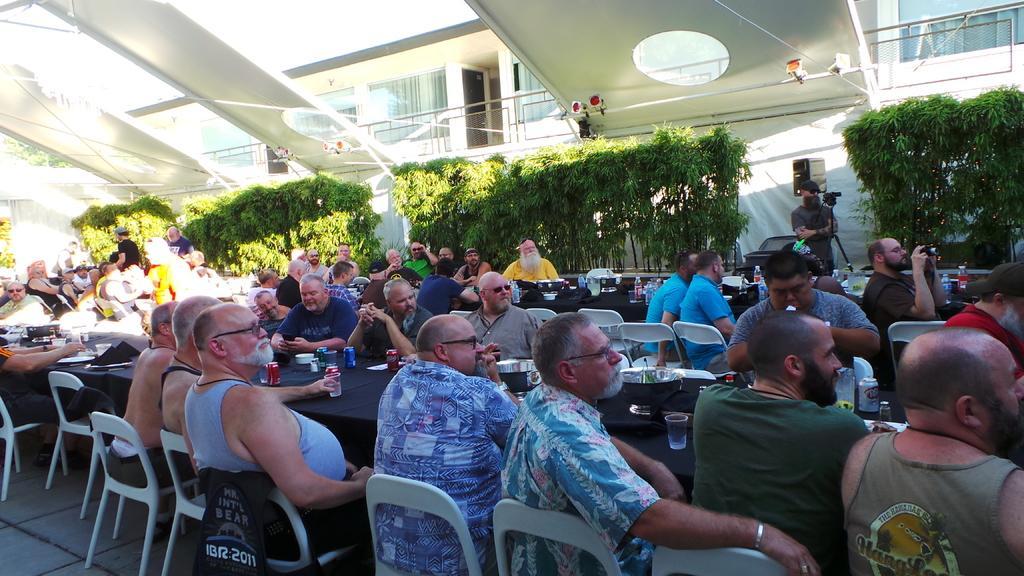How would you summarize this image in a sentence or two? In this picture we can observe many people sitting in the chairs around the table on which some coke tins, glasses and tissues were placed. On the right side there is a man standing in front of a camera. There are some plants. In the background there is a building and a sky. 